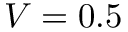<formula> <loc_0><loc_0><loc_500><loc_500>V = 0 . 5</formula> 